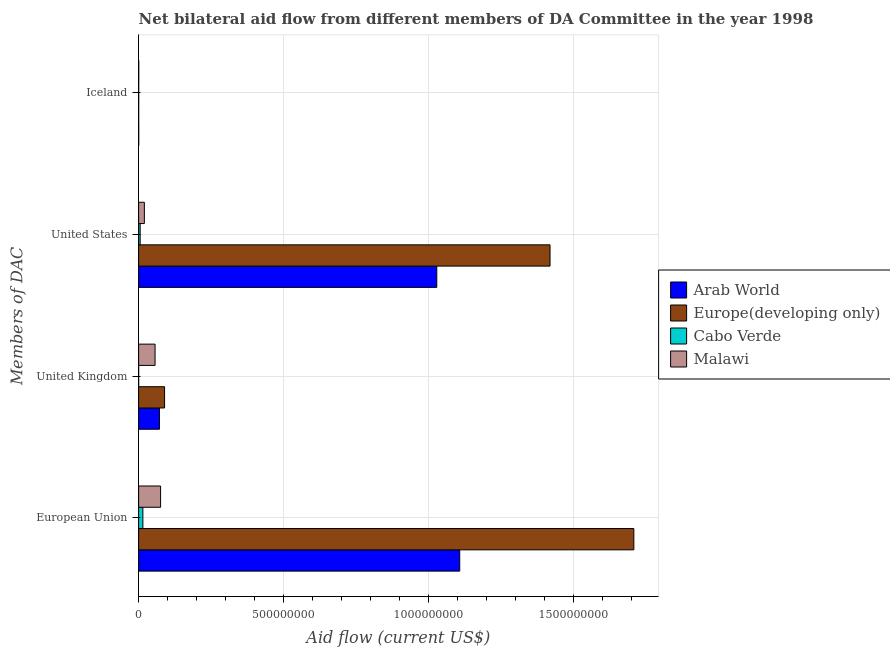How many different coloured bars are there?
Ensure brevity in your answer.  4. Are the number of bars on each tick of the Y-axis equal?
Offer a very short reply. Yes. What is the amount of aid given by eu in Europe(developing only)?
Provide a short and direct response. 1.71e+09. Across all countries, what is the maximum amount of aid given by iceland?
Provide a short and direct response. 4.40e+05. Across all countries, what is the minimum amount of aid given by us?
Ensure brevity in your answer.  5.24e+06. In which country was the amount of aid given by eu maximum?
Your answer should be very brief. Europe(developing only). In which country was the amount of aid given by us minimum?
Keep it short and to the point. Cabo Verde. What is the total amount of aid given by eu in the graph?
Offer a very short reply. 2.90e+09. What is the difference between the amount of aid given by iceland in Arab World and that in Cabo Verde?
Give a very brief answer. 1.10e+05. What is the difference between the amount of aid given by eu in Cabo Verde and the amount of aid given by uk in Europe(developing only)?
Your answer should be compact. -7.47e+07. What is the average amount of aid given by uk per country?
Ensure brevity in your answer.  5.45e+07. What is the difference between the amount of aid given by us and amount of aid given by uk in Malawi?
Your answer should be compact. -3.69e+07. What is the ratio of the amount of aid given by iceland in Cabo Verde to that in Malawi?
Your answer should be very brief. 0.48. What is the difference between the highest and the second highest amount of aid given by uk?
Your response must be concise. 1.76e+07. What is the difference between the highest and the lowest amount of aid given by iceland?
Keep it short and to the point. 3.40e+05. Is the sum of the amount of aid given by eu in Europe(developing only) and Arab World greater than the maximum amount of aid given by us across all countries?
Provide a succinct answer. Yes. Is it the case that in every country, the sum of the amount of aid given by us and amount of aid given by iceland is greater than the sum of amount of aid given by uk and amount of aid given by eu?
Offer a very short reply. No. What does the 4th bar from the top in United States represents?
Keep it short and to the point. Arab World. What does the 4th bar from the bottom in United Kingdom represents?
Your answer should be very brief. Malawi. Is it the case that in every country, the sum of the amount of aid given by eu and amount of aid given by uk is greater than the amount of aid given by us?
Your answer should be compact. Yes. How many bars are there?
Keep it short and to the point. 16. Are all the bars in the graph horizontal?
Make the answer very short. Yes. How many legend labels are there?
Your answer should be very brief. 4. What is the title of the graph?
Give a very brief answer. Net bilateral aid flow from different members of DA Committee in the year 1998. What is the label or title of the Y-axis?
Provide a short and direct response. Members of DAC. What is the Aid flow (current US$) of Arab World in European Union?
Make the answer very short. 1.11e+09. What is the Aid flow (current US$) in Europe(developing only) in European Union?
Make the answer very short. 1.71e+09. What is the Aid flow (current US$) of Cabo Verde in European Union?
Offer a very short reply. 1.47e+07. What is the Aid flow (current US$) in Malawi in European Union?
Give a very brief answer. 7.57e+07. What is the Aid flow (current US$) of Arab World in United Kingdom?
Offer a terse response. 7.18e+07. What is the Aid flow (current US$) of Europe(developing only) in United Kingdom?
Offer a terse response. 8.94e+07. What is the Aid flow (current US$) in Cabo Verde in United Kingdom?
Provide a succinct answer. 4.00e+04. What is the Aid flow (current US$) in Malawi in United Kingdom?
Offer a very short reply. 5.66e+07. What is the Aid flow (current US$) in Arab World in United States?
Give a very brief answer. 1.03e+09. What is the Aid flow (current US$) in Europe(developing only) in United States?
Make the answer very short. 1.42e+09. What is the Aid flow (current US$) in Cabo Verde in United States?
Ensure brevity in your answer.  5.24e+06. What is the Aid flow (current US$) in Malawi in United States?
Your answer should be very brief. 1.97e+07. What is the Aid flow (current US$) of Europe(developing only) in Iceland?
Make the answer very short. 1.00e+05. Across all Members of DAC, what is the maximum Aid flow (current US$) in Arab World?
Your answer should be very brief. 1.11e+09. Across all Members of DAC, what is the maximum Aid flow (current US$) in Europe(developing only)?
Give a very brief answer. 1.71e+09. Across all Members of DAC, what is the maximum Aid flow (current US$) of Cabo Verde?
Your answer should be compact. 1.47e+07. Across all Members of DAC, what is the maximum Aid flow (current US$) in Malawi?
Your answer should be very brief. 7.57e+07. Across all Members of DAC, what is the minimum Aid flow (current US$) of Europe(developing only)?
Provide a short and direct response. 1.00e+05. Across all Members of DAC, what is the minimum Aid flow (current US$) of Cabo Verde?
Provide a succinct answer. 4.00e+04. Across all Members of DAC, what is the minimum Aid flow (current US$) of Malawi?
Give a very brief answer. 4.40e+05. What is the total Aid flow (current US$) in Arab World in the graph?
Offer a terse response. 2.21e+09. What is the total Aid flow (current US$) in Europe(developing only) in the graph?
Keep it short and to the point. 3.21e+09. What is the total Aid flow (current US$) of Cabo Verde in the graph?
Ensure brevity in your answer.  2.02e+07. What is the total Aid flow (current US$) in Malawi in the graph?
Offer a terse response. 1.53e+08. What is the difference between the Aid flow (current US$) of Arab World in European Union and that in United Kingdom?
Make the answer very short. 1.03e+09. What is the difference between the Aid flow (current US$) of Europe(developing only) in European Union and that in United Kingdom?
Provide a short and direct response. 1.62e+09. What is the difference between the Aid flow (current US$) in Cabo Verde in European Union and that in United Kingdom?
Provide a short and direct response. 1.46e+07. What is the difference between the Aid flow (current US$) in Malawi in European Union and that in United Kingdom?
Offer a terse response. 1.90e+07. What is the difference between the Aid flow (current US$) in Arab World in European Union and that in United States?
Your answer should be very brief. 7.91e+07. What is the difference between the Aid flow (current US$) in Europe(developing only) in European Union and that in United States?
Your answer should be very brief. 2.89e+08. What is the difference between the Aid flow (current US$) of Cabo Verde in European Union and that in United States?
Make the answer very short. 9.42e+06. What is the difference between the Aid flow (current US$) in Malawi in European Union and that in United States?
Offer a very short reply. 5.60e+07. What is the difference between the Aid flow (current US$) in Arab World in European Union and that in Iceland?
Keep it short and to the point. 1.11e+09. What is the difference between the Aid flow (current US$) of Europe(developing only) in European Union and that in Iceland?
Offer a very short reply. 1.71e+09. What is the difference between the Aid flow (current US$) of Cabo Verde in European Union and that in Iceland?
Provide a short and direct response. 1.44e+07. What is the difference between the Aid flow (current US$) of Malawi in European Union and that in Iceland?
Give a very brief answer. 7.53e+07. What is the difference between the Aid flow (current US$) of Arab World in United Kingdom and that in United States?
Offer a very short reply. -9.56e+08. What is the difference between the Aid flow (current US$) in Europe(developing only) in United Kingdom and that in United States?
Your answer should be compact. -1.33e+09. What is the difference between the Aid flow (current US$) of Cabo Verde in United Kingdom and that in United States?
Provide a succinct answer. -5.20e+06. What is the difference between the Aid flow (current US$) in Malawi in United Kingdom and that in United States?
Offer a terse response. 3.69e+07. What is the difference between the Aid flow (current US$) of Arab World in United Kingdom and that in Iceland?
Your response must be concise. 7.15e+07. What is the difference between the Aid flow (current US$) in Europe(developing only) in United Kingdom and that in Iceland?
Your answer should be very brief. 8.93e+07. What is the difference between the Aid flow (current US$) of Cabo Verde in United Kingdom and that in Iceland?
Provide a short and direct response. -1.70e+05. What is the difference between the Aid flow (current US$) of Malawi in United Kingdom and that in Iceland?
Ensure brevity in your answer.  5.62e+07. What is the difference between the Aid flow (current US$) of Arab World in United States and that in Iceland?
Provide a succinct answer. 1.03e+09. What is the difference between the Aid flow (current US$) of Europe(developing only) in United States and that in Iceland?
Your answer should be compact. 1.42e+09. What is the difference between the Aid flow (current US$) in Cabo Verde in United States and that in Iceland?
Provide a short and direct response. 5.03e+06. What is the difference between the Aid flow (current US$) in Malawi in United States and that in Iceland?
Offer a terse response. 1.93e+07. What is the difference between the Aid flow (current US$) in Arab World in European Union and the Aid flow (current US$) in Europe(developing only) in United Kingdom?
Make the answer very short. 1.02e+09. What is the difference between the Aid flow (current US$) of Arab World in European Union and the Aid flow (current US$) of Cabo Verde in United Kingdom?
Provide a succinct answer. 1.11e+09. What is the difference between the Aid flow (current US$) in Arab World in European Union and the Aid flow (current US$) in Malawi in United Kingdom?
Make the answer very short. 1.05e+09. What is the difference between the Aid flow (current US$) of Europe(developing only) in European Union and the Aid flow (current US$) of Cabo Verde in United Kingdom?
Give a very brief answer. 1.71e+09. What is the difference between the Aid flow (current US$) of Europe(developing only) in European Union and the Aid flow (current US$) of Malawi in United Kingdom?
Your answer should be compact. 1.65e+09. What is the difference between the Aid flow (current US$) in Cabo Verde in European Union and the Aid flow (current US$) in Malawi in United Kingdom?
Your response must be concise. -4.20e+07. What is the difference between the Aid flow (current US$) in Arab World in European Union and the Aid flow (current US$) in Europe(developing only) in United States?
Offer a terse response. -3.11e+08. What is the difference between the Aid flow (current US$) in Arab World in European Union and the Aid flow (current US$) in Cabo Verde in United States?
Make the answer very short. 1.10e+09. What is the difference between the Aid flow (current US$) in Arab World in European Union and the Aid flow (current US$) in Malawi in United States?
Give a very brief answer. 1.09e+09. What is the difference between the Aid flow (current US$) of Europe(developing only) in European Union and the Aid flow (current US$) of Cabo Verde in United States?
Ensure brevity in your answer.  1.70e+09. What is the difference between the Aid flow (current US$) of Europe(developing only) in European Union and the Aid flow (current US$) of Malawi in United States?
Keep it short and to the point. 1.69e+09. What is the difference between the Aid flow (current US$) in Cabo Verde in European Union and the Aid flow (current US$) in Malawi in United States?
Make the answer very short. -5.07e+06. What is the difference between the Aid flow (current US$) in Arab World in European Union and the Aid flow (current US$) in Europe(developing only) in Iceland?
Make the answer very short. 1.11e+09. What is the difference between the Aid flow (current US$) in Arab World in European Union and the Aid flow (current US$) in Cabo Verde in Iceland?
Provide a succinct answer. 1.11e+09. What is the difference between the Aid flow (current US$) in Arab World in European Union and the Aid flow (current US$) in Malawi in Iceland?
Make the answer very short. 1.11e+09. What is the difference between the Aid flow (current US$) of Europe(developing only) in European Union and the Aid flow (current US$) of Cabo Verde in Iceland?
Keep it short and to the point. 1.71e+09. What is the difference between the Aid flow (current US$) of Europe(developing only) in European Union and the Aid flow (current US$) of Malawi in Iceland?
Provide a succinct answer. 1.71e+09. What is the difference between the Aid flow (current US$) of Cabo Verde in European Union and the Aid flow (current US$) of Malawi in Iceland?
Your response must be concise. 1.42e+07. What is the difference between the Aid flow (current US$) of Arab World in United Kingdom and the Aid flow (current US$) of Europe(developing only) in United States?
Provide a short and direct response. -1.35e+09. What is the difference between the Aid flow (current US$) in Arab World in United Kingdom and the Aid flow (current US$) in Cabo Verde in United States?
Offer a terse response. 6.66e+07. What is the difference between the Aid flow (current US$) of Arab World in United Kingdom and the Aid flow (current US$) of Malawi in United States?
Keep it short and to the point. 5.21e+07. What is the difference between the Aid flow (current US$) in Europe(developing only) in United Kingdom and the Aid flow (current US$) in Cabo Verde in United States?
Your response must be concise. 8.42e+07. What is the difference between the Aid flow (current US$) in Europe(developing only) in United Kingdom and the Aid flow (current US$) in Malawi in United States?
Ensure brevity in your answer.  6.97e+07. What is the difference between the Aid flow (current US$) of Cabo Verde in United Kingdom and the Aid flow (current US$) of Malawi in United States?
Your answer should be compact. -1.97e+07. What is the difference between the Aid flow (current US$) in Arab World in United Kingdom and the Aid flow (current US$) in Europe(developing only) in Iceland?
Offer a very short reply. 7.17e+07. What is the difference between the Aid flow (current US$) of Arab World in United Kingdom and the Aid flow (current US$) of Cabo Verde in Iceland?
Your response must be concise. 7.16e+07. What is the difference between the Aid flow (current US$) of Arab World in United Kingdom and the Aid flow (current US$) of Malawi in Iceland?
Your answer should be very brief. 7.14e+07. What is the difference between the Aid flow (current US$) of Europe(developing only) in United Kingdom and the Aid flow (current US$) of Cabo Verde in Iceland?
Your response must be concise. 8.92e+07. What is the difference between the Aid flow (current US$) in Europe(developing only) in United Kingdom and the Aid flow (current US$) in Malawi in Iceland?
Give a very brief answer. 8.90e+07. What is the difference between the Aid flow (current US$) of Cabo Verde in United Kingdom and the Aid flow (current US$) of Malawi in Iceland?
Your answer should be compact. -4.00e+05. What is the difference between the Aid flow (current US$) of Arab World in United States and the Aid flow (current US$) of Europe(developing only) in Iceland?
Offer a terse response. 1.03e+09. What is the difference between the Aid flow (current US$) in Arab World in United States and the Aid flow (current US$) in Cabo Verde in Iceland?
Provide a succinct answer. 1.03e+09. What is the difference between the Aid flow (current US$) of Arab World in United States and the Aid flow (current US$) of Malawi in Iceland?
Provide a short and direct response. 1.03e+09. What is the difference between the Aid flow (current US$) in Europe(developing only) in United States and the Aid flow (current US$) in Cabo Verde in Iceland?
Offer a terse response. 1.42e+09. What is the difference between the Aid flow (current US$) of Europe(developing only) in United States and the Aid flow (current US$) of Malawi in Iceland?
Offer a terse response. 1.42e+09. What is the difference between the Aid flow (current US$) in Cabo Verde in United States and the Aid flow (current US$) in Malawi in Iceland?
Your response must be concise. 4.80e+06. What is the average Aid flow (current US$) of Arab World per Members of DAC?
Your answer should be compact. 5.52e+08. What is the average Aid flow (current US$) of Europe(developing only) per Members of DAC?
Offer a very short reply. 8.04e+08. What is the average Aid flow (current US$) in Cabo Verde per Members of DAC?
Keep it short and to the point. 5.04e+06. What is the average Aid flow (current US$) of Malawi per Members of DAC?
Your answer should be compact. 3.81e+07. What is the difference between the Aid flow (current US$) of Arab World and Aid flow (current US$) of Europe(developing only) in European Union?
Make the answer very short. -6.00e+08. What is the difference between the Aid flow (current US$) of Arab World and Aid flow (current US$) of Cabo Verde in European Union?
Make the answer very short. 1.09e+09. What is the difference between the Aid flow (current US$) of Arab World and Aid flow (current US$) of Malawi in European Union?
Ensure brevity in your answer.  1.03e+09. What is the difference between the Aid flow (current US$) of Europe(developing only) and Aid flow (current US$) of Cabo Verde in European Union?
Provide a succinct answer. 1.69e+09. What is the difference between the Aid flow (current US$) in Europe(developing only) and Aid flow (current US$) in Malawi in European Union?
Your response must be concise. 1.63e+09. What is the difference between the Aid flow (current US$) in Cabo Verde and Aid flow (current US$) in Malawi in European Union?
Your answer should be compact. -6.10e+07. What is the difference between the Aid flow (current US$) in Arab World and Aid flow (current US$) in Europe(developing only) in United Kingdom?
Offer a very short reply. -1.76e+07. What is the difference between the Aid flow (current US$) of Arab World and Aid flow (current US$) of Cabo Verde in United Kingdom?
Offer a very short reply. 7.18e+07. What is the difference between the Aid flow (current US$) of Arab World and Aid flow (current US$) of Malawi in United Kingdom?
Provide a short and direct response. 1.52e+07. What is the difference between the Aid flow (current US$) in Europe(developing only) and Aid flow (current US$) in Cabo Verde in United Kingdom?
Keep it short and to the point. 8.94e+07. What is the difference between the Aid flow (current US$) of Europe(developing only) and Aid flow (current US$) of Malawi in United Kingdom?
Give a very brief answer. 3.28e+07. What is the difference between the Aid flow (current US$) in Cabo Verde and Aid flow (current US$) in Malawi in United Kingdom?
Keep it short and to the point. -5.66e+07. What is the difference between the Aid flow (current US$) in Arab World and Aid flow (current US$) in Europe(developing only) in United States?
Offer a very short reply. -3.90e+08. What is the difference between the Aid flow (current US$) in Arab World and Aid flow (current US$) in Cabo Verde in United States?
Ensure brevity in your answer.  1.02e+09. What is the difference between the Aid flow (current US$) of Arab World and Aid flow (current US$) of Malawi in United States?
Keep it short and to the point. 1.01e+09. What is the difference between the Aid flow (current US$) of Europe(developing only) and Aid flow (current US$) of Cabo Verde in United States?
Your answer should be compact. 1.41e+09. What is the difference between the Aid flow (current US$) of Europe(developing only) and Aid flow (current US$) of Malawi in United States?
Ensure brevity in your answer.  1.40e+09. What is the difference between the Aid flow (current US$) in Cabo Verde and Aid flow (current US$) in Malawi in United States?
Make the answer very short. -1.45e+07. What is the difference between the Aid flow (current US$) of Europe(developing only) and Aid flow (current US$) of Cabo Verde in Iceland?
Offer a very short reply. -1.10e+05. What is the difference between the Aid flow (current US$) of Cabo Verde and Aid flow (current US$) of Malawi in Iceland?
Provide a short and direct response. -2.30e+05. What is the ratio of the Aid flow (current US$) in Arab World in European Union to that in United Kingdom?
Make the answer very short. 15.41. What is the ratio of the Aid flow (current US$) of Europe(developing only) in European Union to that in United Kingdom?
Offer a terse response. 19.09. What is the ratio of the Aid flow (current US$) in Cabo Verde in European Union to that in United Kingdom?
Provide a short and direct response. 366.5. What is the ratio of the Aid flow (current US$) of Malawi in European Union to that in United Kingdom?
Provide a short and direct response. 1.34. What is the ratio of the Aid flow (current US$) in Arab World in European Union to that in United States?
Ensure brevity in your answer.  1.08. What is the ratio of the Aid flow (current US$) of Europe(developing only) in European Union to that in United States?
Your response must be concise. 1.2. What is the ratio of the Aid flow (current US$) of Cabo Verde in European Union to that in United States?
Your answer should be compact. 2.8. What is the ratio of the Aid flow (current US$) of Malawi in European Union to that in United States?
Your answer should be compact. 3.84. What is the ratio of the Aid flow (current US$) in Arab World in European Union to that in Iceland?
Your response must be concise. 3458.5. What is the ratio of the Aid flow (current US$) of Europe(developing only) in European Union to that in Iceland?
Offer a terse response. 1.71e+04. What is the ratio of the Aid flow (current US$) of Cabo Verde in European Union to that in Iceland?
Make the answer very short. 69.81. What is the ratio of the Aid flow (current US$) in Malawi in European Union to that in Iceland?
Your answer should be compact. 172.05. What is the ratio of the Aid flow (current US$) of Arab World in United Kingdom to that in United States?
Provide a short and direct response. 0.07. What is the ratio of the Aid flow (current US$) of Europe(developing only) in United Kingdom to that in United States?
Make the answer very short. 0.06. What is the ratio of the Aid flow (current US$) in Cabo Verde in United Kingdom to that in United States?
Your response must be concise. 0.01. What is the ratio of the Aid flow (current US$) of Malawi in United Kingdom to that in United States?
Your answer should be compact. 2.87. What is the ratio of the Aid flow (current US$) in Arab World in United Kingdom to that in Iceland?
Keep it short and to the point. 224.5. What is the ratio of the Aid flow (current US$) of Europe(developing only) in United Kingdom to that in Iceland?
Give a very brief answer. 894. What is the ratio of the Aid flow (current US$) of Cabo Verde in United Kingdom to that in Iceland?
Your response must be concise. 0.19. What is the ratio of the Aid flow (current US$) in Malawi in United Kingdom to that in Iceland?
Provide a succinct answer. 128.75. What is the ratio of the Aid flow (current US$) in Arab World in United States to that in Iceland?
Give a very brief answer. 3211.31. What is the ratio of the Aid flow (current US$) of Europe(developing only) in United States to that in Iceland?
Provide a succinct answer. 1.42e+04. What is the ratio of the Aid flow (current US$) in Cabo Verde in United States to that in Iceland?
Provide a short and direct response. 24.95. What is the ratio of the Aid flow (current US$) in Malawi in United States to that in Iceland?
Offer a very short reply. 44.84. What is the difference between the highest and the second highest Aid flow (current US$) of Arab World?
Your answer should be very brief. 7.91e+07. What is the difference between the highest and the second highest Aid flow (current US$) in Europe(developing only)?
Offer a very short reply. 2.89e+08. What is the difference between the highest and the second highest Aid flow (current US$) of Cabo Verde?
Make the answer very short. 9.42e+06. What is the difference between the highest and the second highest Aid flow (current US$) of Malawi?
Make the answer very short. 1.90e+07. What is the difference between the highest and the lowest Aid flow (current US$) in Arab World?
Make the answer very short. 1.11e+09. What is the difference between the highest and the lowest Aid flow (current US$) in Europe(developing only)?
Your answer should be very brief. 1.71e+09. What is the difference between the highest and the lowest Aid flow (current US$) of Cabo Verde?
Make the answer very short. 1.46e+07. What is the difference between the highest and the lowest Aid flow (current US$) in Malawi?
Your answer should be compact. 7.53e+07. 